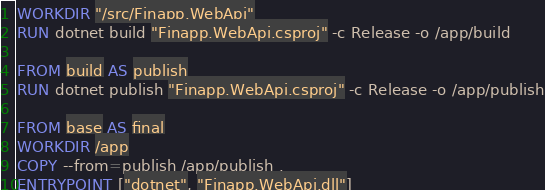Convert code to text. <code><loc_0><loc_0><loc_500><loc_500><_Dockerfile_>WORKDIR "/src/Finapp.WebApi"
RUN dotnet build "Finapp.WebApi.csproj" -c Release -o /app/build

FROM build AS publish
RUN dotnet publish "Finapp.WebApi.csproj" -c Release -o /app/publish

FROM base AS final
WORKDIR /app
COPY --from=publish /app/publish .
ENTRYPOINT ["dotnet", "Finapp.WebApi.dll"]
</code> 